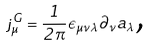Convert formula to latex. <formula><loc_0><loc_0><loc_500><loc_500>j ^ { G } _ { \mu } = \frac { 1 } { 2 \pi } \epsilon _ { \mu \nu \lambda } \partial _ { \nu } a _ { \lambda } \text {,}</formula> 